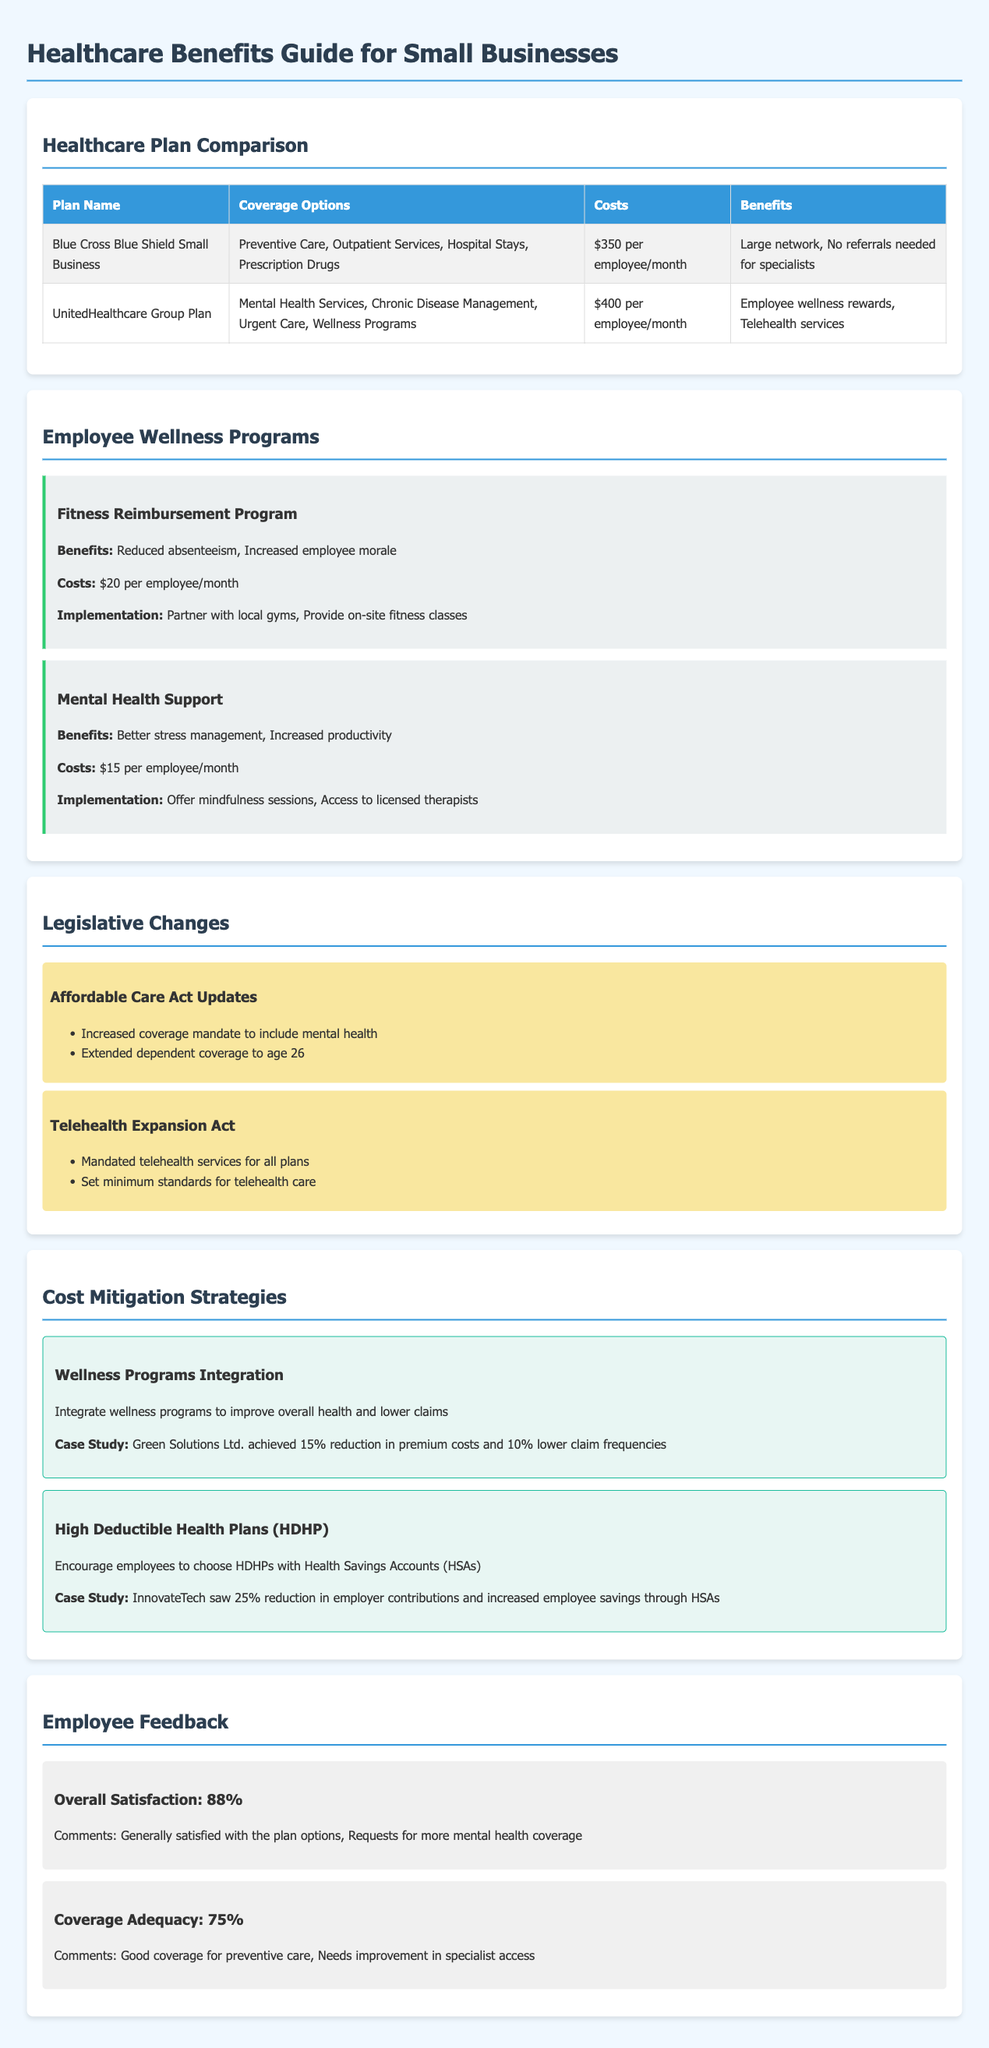what is the cost of the Blue Cross Blue Shield Small Business plan? The cost for this plan is specified in the healthcare plan comparison section of the document.
Answer: $350 per employee/month what type of services does UnitedHealthcare Group Plan cover? The comparison of healthcare plans lists the various coverage options for the UnitedHealthcare Group Plan.
Answer: Mental Health Services, Chronic Disease Management, Urgent Care, Wellness Programs what is one benefit of the Fitness Reimbursement Program? The wellness programs section outlines several benefits of the Fitness Reimbursement Program.
Answer: Reduced absenteeism how many updates are listed under the Affordable Care Act Updates? The legislative changes section provides a summary of updates for easier review.
Answer: 2 what percentage of employees expressed overall satisfaction with their healthcare plans? Employee feedback summarizes the satisfaction survey results regarding healthcare plans.
Answer: 88% what was the reduction in premium costs achieved by Green Solutions Ltd.? The cost mitigation strategies section includes a case study with specific reductions in premium costs.
Answer: 15% which program has a monthly cost of $15 per employee? The wellness programs section lists costs for different programs, identifying specific ones.
Answer: Mental Health Support what is the primary focus of the High Deductible Health Plans (HDHP) strategy? The cost mitigation strategies section discusses the focus of the HDHP strategy for employee healthcare.
Answer: Encourage employees to choose HDHPs with Health Savings Accounts (HSAs) 